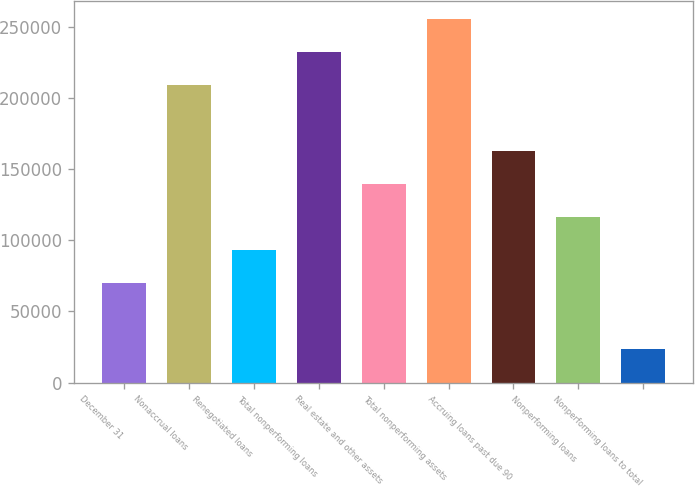<chart> <loc_0><loc_0><loc_500><loc_500><bar_chart><fcel>December 31<fcel>Nonaccrual loans<fcel>Renegotiated loans<fcel>Total nonperforming loans<fcel>Real estate and other assets<fcel>Total nonperforming assets<fcel>Accruing loans past due 90<fcel>Nonperforming loans<fcel>Nonperforming loans to total<nl><fcel>69801.4<fcel>209403<fcel>93068.4<fcel>232670<fcel>139602<fcel>255937<fcel>162869<fcel>116335<fcel>23267.5<nl></chart> 